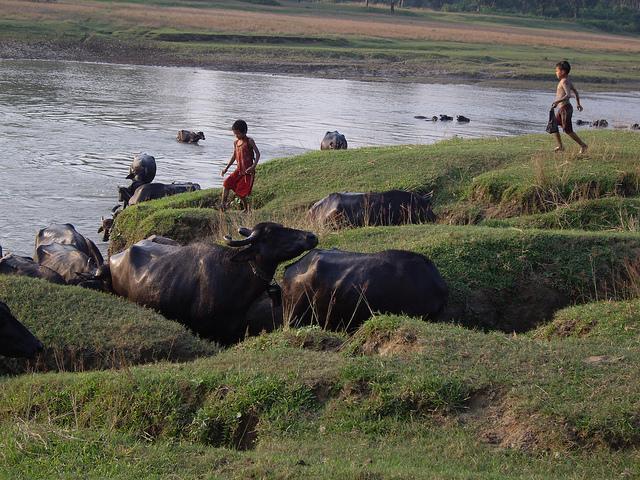How many children are running onto the cape with the water cows?
Indicate the correct choice and explain in the format: 'Answer: answer
Rationale: rationale.'
Options: Five, four, three, two. Answer: two.
Rationale: You can see two small humans. 